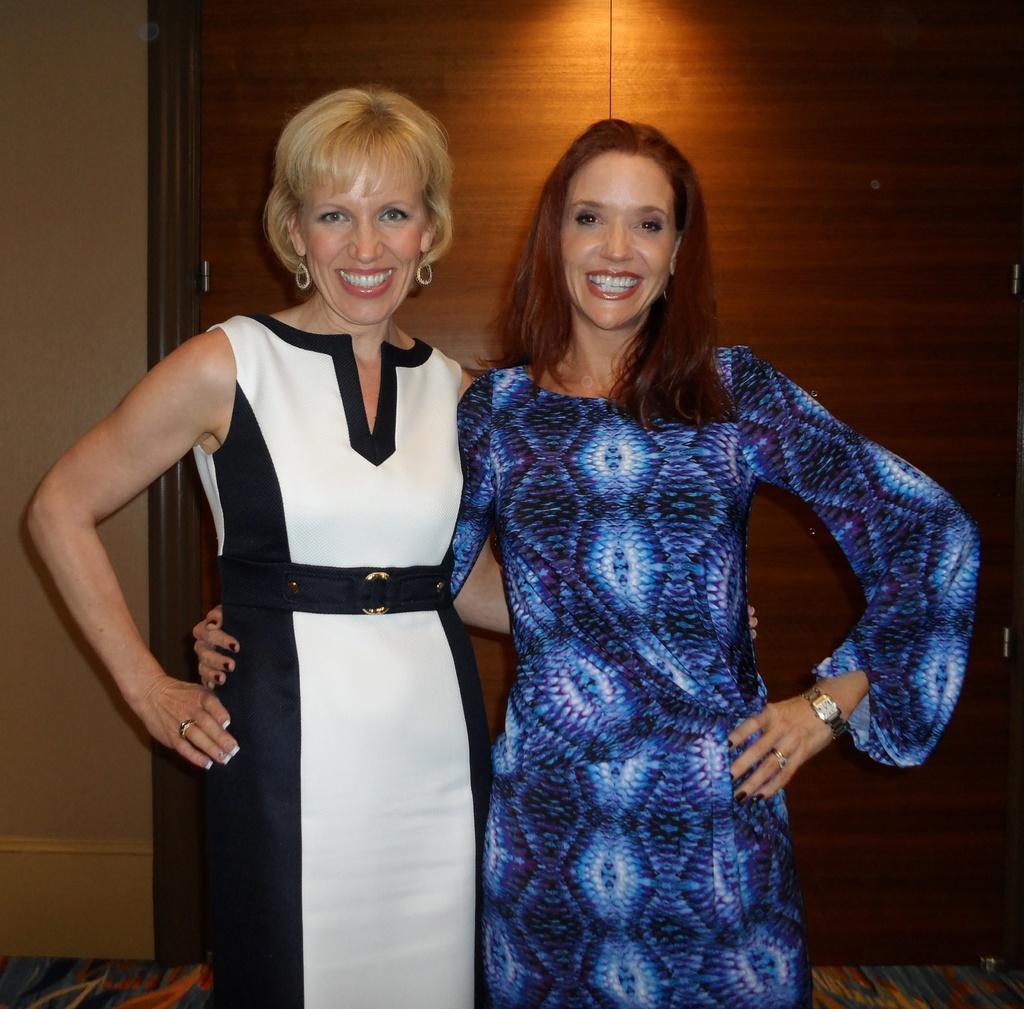Could you give a brief overview of what you see in this image? In this image we can see two women standing holding each other. On the backside we can see a wall and a wooden door. 